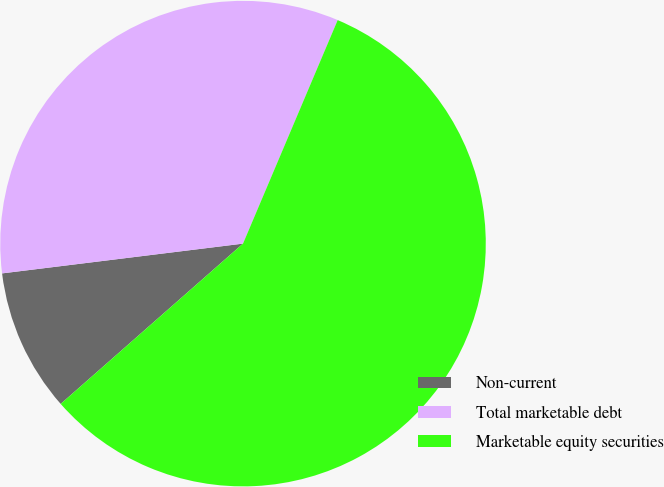Convert chart. <chart><loc_0><loc_0><loc_500><loc_500><pie_chart><fcel>Non-current<fcel>Total marketable debt<fcel>Marketable equity securities<nl><fcel>9.52%<fcel>33.33%<fcel>57.14%<nl></chart> 